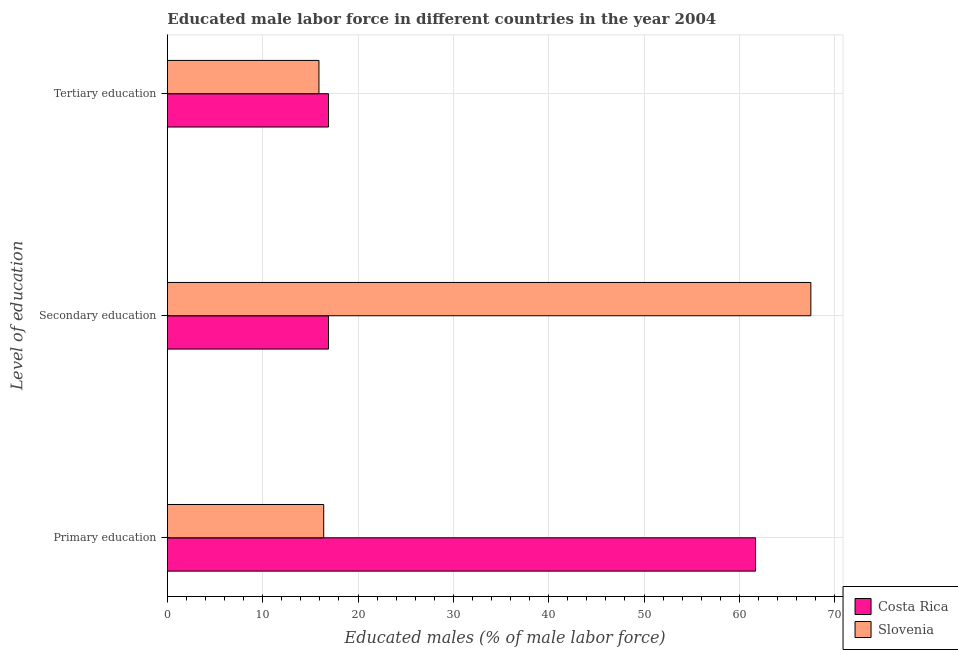How many bars are there on the 2nd tick from the top?
Offer a very short reply. 2. How many bars are there on the 3rd tick from the bottom?
Your response must be concise. 2. What is the label of the 3rd group of bars from the top?
Ensure brevity in your answer.  Primary education. What is the percentage of male labor force who received primary education in Slovenia?
Make the answer very short. 16.4. Across all countries, what is the maximum percentage of male labor force who received tertiary education?
Ensure brevity in your answer.  16.9. Across all countries, what is the minimum percentage of male labor force who received secondary education?
Your answer should be compact. 16.9. In which country was the percentage of male labor force who received primary education maximum?
Give a very brief answer. Costa Rica. In which country was the percentage of male labor force who received secondary education minimum?
Offer a terse response. Costa Rica. What is the total percentage of male labor force who received secondary education in the graph?
Provide a short and direct response. 84.4. What is the difference between the percentage of male labor force who received primary education in Slovenia and that in Costa Rica?
Provide a short and direct response. -45.3. What is the difference between the percentage of male labor force who received primary education in Costa Rica and the percentage of male labor force who received secondary education in Slovenia?
Keep it short and to the point. -5.8. What is the average percentage of male labor force who received tertiary education per country?
Your response must be concise. 16.4. In how many countries, is the percentage of male labor force who received tertiary education greater than 2 %?
Your answer should be compact. 2. What is the ratio of the percentage of male labor force who received tertiary education in Costa Rica to that in Slovenia?
Offer a terse response. 1.06. What is the difference between the highest and the second highest percentage of male labor force who received tertiary education?
Ensure brevity in your answer.  1. What is the difference between the highest and the lowest percentage of male labor force who received primary education?
Your response must be concise. 45.3. In how many countries, is the percentage of male labor force who received secondary education greater than the average percentage of male labor force who received secondary education taken over all countries?
Give a very brief answer. 1. What does the 1st bar from the top in Primary education represents?
Give a very brief answer. Slovenia. What does the 1st bar from the bottom in Tertiary education represents?
Make the answer very short. Costa Rica. Are all the bars in the graph horizontal?
Your answer should be very brief. Yes. Does the graph contain any zero values?
Make the answer very short. No. How are the legend labels stacked?
Provide a succinct answer. Vertical. What is the title of the graph?
Your answer should be very brief. Educated male labor force in different countries in the year 2004. What is the label or title of the X-axis?
Your answer should be very brief. Educated males (% of male labor force). What is the label or title of the Y-axis?
Make the answer very short. Level of education. What is the Educated males (% of male labor force) of Costa Rica in Primary education?
Keep it short and to the point. 61.7. What is the Educated males (% of male labor force) of Slovenia in Primary education?
Offer a very short reply. 16.4. What is the Educated males (% of male labor force) in Costa Rica in Secondary education?
Offer a terse response. 16.9. What is the Educated males (% of male labor force) in Slovenia in Secondary education?
Give a very brief answer. 67.5. What is the Educated males (% of male labor force) in Costa Rica in Tertiary education?
Keep it short and to the point. 16.9. What is the Educated males (% of male labor force) in Slovenia in Tertiary education?
Your response must be concise. 15.9. Across all Level of education, what is the maximum Educated males (% of male labor force) in Costa Rica?
Provide a short and direct response. 61.7. Across all Level of education, what is the maximum Educated males (% of male labor force) in Slovenia?
Make the answer very short. 67.5. Across all Level of education, what is the minimum Educated males (% of male labor force) in Costa Rica?
Offer a very short reply. 16.9. Across all Level of education, what is the minimum Educated males (% of male labor force) of Slovenia?
Ensure brevity in your answer.  15.9. What is the total Educated males (% of male labor force) of Costa Rica in the graph?
Make the answer very short. 95.5. What is the total Educated males (% of male labor force) in Slovenia in the graph?
Your response must be concise. 99.8. What is the difference between the Educated males (% of male labor force) of Costa Rica in Primary education and that in Secondary education?
Your answer should be compact. 44.8. What is the difference between the Educated males (% of male labor force) in Slovenia in Primary education and that in Secondary education?
Provide a short and direct response. -51.1. What is the difference between the Educated males (% of male labor force) in Costa Rica in Primary education and that in Tertiary education?
Offer a very short reply. 44.8. What is the difference between the Educated males (% of male labor force) in Slovenia in Secondary education and that in Tertiary education?
Provide a succinct answer. 51.6. What is the difference between the Educated males (% of male labor force) of Costa Rica in Primary education and the Educated males (% of male labor force) of Slovenia in Secondary education?
Keep it short and to the point. -5.8. What is the difference between the Educated males (% of male labor force) of Costa Rica in Primary education and the Educated males (% of male labor force) of Slovenia in Tertiary education?
Your response must be concise. 45.8. What is the average Educated males (% of male labor force) in Costa Rica per Level of education?
Offer a terse response. 31.83. What is the average Educated males (% of male labor force) in Slovenia per Level of education?
Give a very brief answer. 33.27. What is the difference between the Educated males (% of male labor force) of Costa Rica and Educated males (% of male labor force) of Slovenia in Primary education?
Provide a succinct answer. 45.3. What is the difference between the Educated males (% of male labor force) in Costa Rica and Educated males (% of male labor force) in Slovenia in Secondary education?
Give a very brief answer. -50.6. What is the ratio of the Educated males (% of male labor force) in Costa Rica in Primary education to that in Secondary education?
Offer a terse response. 3.65. What is the ratio of the Educated males (% of male labor force) in Slovenia in Primary education to that in Secondary education?
Provide a succinct answer. 0.24. What is the ratio of the Educated males (% of male labor force) of Costa Rica in Primary education to that in Tertiary education?
Keep it short and to the point. 3.65. What is the ratio of the Educated males (% of male labor force) in Slovenia in Primary education to that in Tertiary education?
Offer a very short reply. 1.03. What is the ratio of the Educated males (% of male labor force) in Costa Rica in Secondary education to that in Tertiary education?
Offer a very short reply. 1. What is the ratio of the Educated males (% of male labor force) in Slovenia in Secondary education to that in Tertiary education?
Your answer should be very brief. 4.25. What is the difference between the highest and the second highest Educated males (% of male labor force) in Costa Rica?
Make the answer very short. 44.8. What is the difference between the highest and the second highest Educated males (% of male labor force) of Slovenia?
Your response must be concise. 51.1. What is the difference between the highest and the lowest Educated males (% of male labor force) in Costa Rica?
Your answer should be compact. 44.8. What is the difference between the highest and the lowest Educated males (% of male labor force) of Slovenia?
Give a very brief answer. 51.6. 